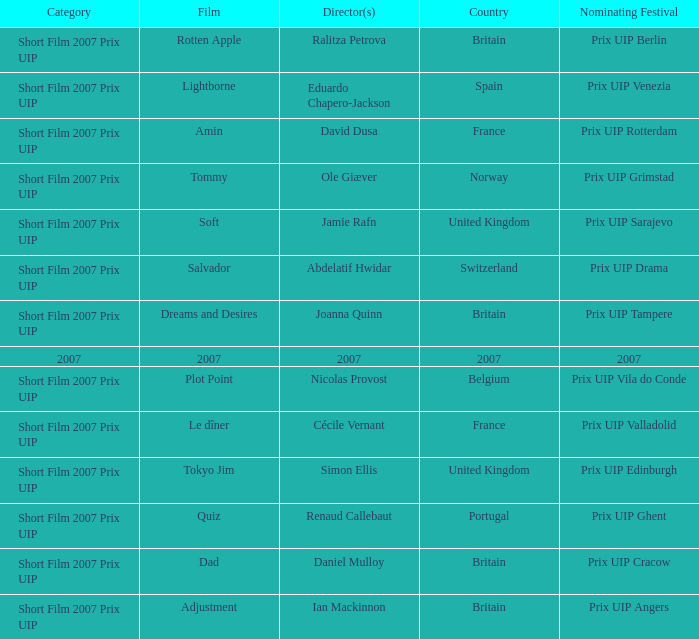What film did ian mackinnon direct that was in the short film 2007 prix uip category? Adjustment. 